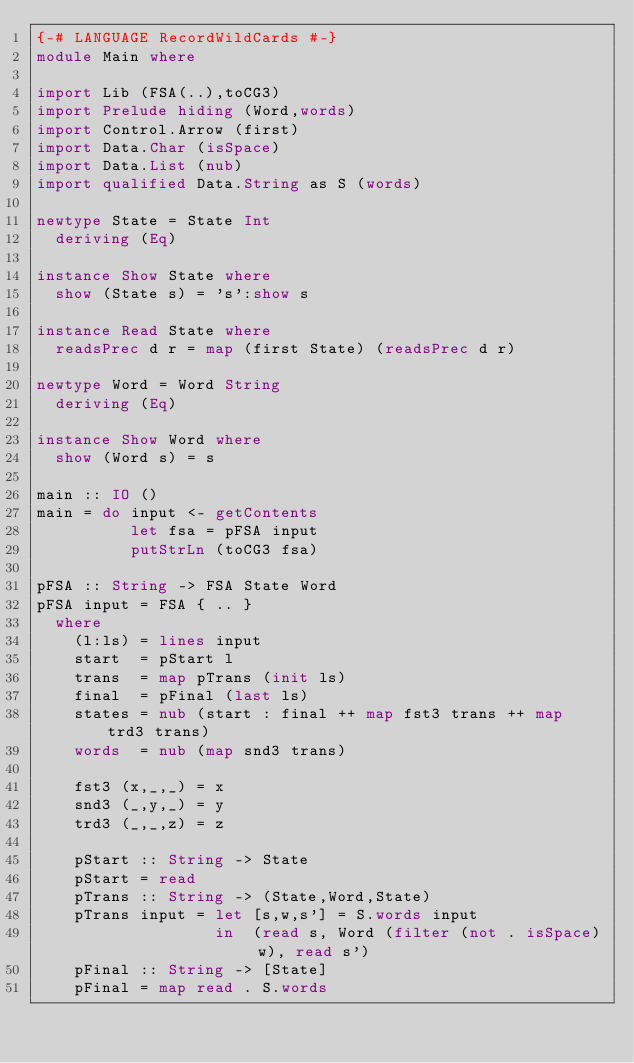<code> <loc_0><loc_0><loc_500><loc_500><_Haskell_>{-# LANGUAGE RecordWildCards #-}
module Main where

import Lib (FSA(..),toCG3)
import Prelude hiding (Word,words)
import Control.Arrow (first)
import Data.Char (isSpace)
import Data.List (nub)
import qualified Data.String as S (words)

newtype State = State Int
  deriving (Eq)

instance Show State where
  show (State s) = 's':show s

instance Read State where
  readsPrec d r = map (first State) (readsPrec d r)

newtype Word = Word String
  deriving (Eq)

instance Show Word where
  show (Word s) = s

main :: IO ()
main = do input <- getContents
          let fsa = pFSA input
          putStrLn (toCG3 fsa)

pFSA :: String -> FSA State Word
pFSA input = FSA { .. }
  where
    (l:ls) = lines input
    start  = pStart l
    trans  = map pTrans (init ls)
    final  = pFinal (last ls)
    states = nub (start : final ++ map fst3 trans ++ map trd3 trans)
    words  = nub (map snd3 trans)

    fst3 (x,_,_) = x
    snd3 (_,y,_) = y
    trd3 (_,_,z) = z

    pStart :: String -> State
    pStart = read
    pTrans :: String -> (State,Word,State)
    pTrans input = let [s,w,s'] = S.words input
                   in  (read s, Word (filter (not . isSpace) w), read s')
    pFinal :: String -> [State]
    pFinal = map read . S.words
</code> 